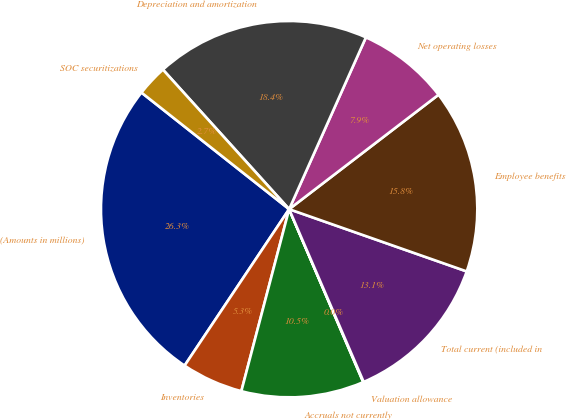<chart> <loc_0><loc_0><loc_500><loc_500><pie_chart><fcel>(Amounts in millions)<fcel>Inventories<fcel>Accruals not currently<fcel>Valuation allowance<fcel>Total current (included in<fcel>Employee benefits<fcel>Net operating losses<fcel>Depreciation and amortization<fcel>SOC securitizations<nl><fcel>26.26%<fcel>5.29%<fcel>10.53%<fcel>0.04%<fcel>13.15%<fcel>15.77%<fcel>7.91%<fcel>18.39%<fcel>2.66%<nl></chart> 